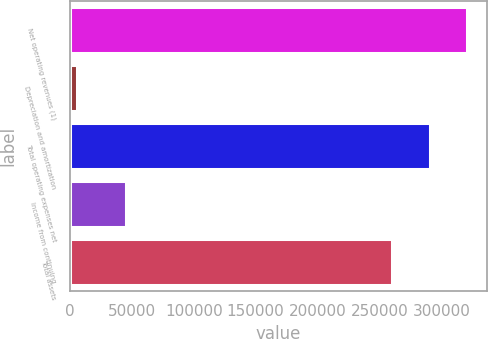Convert chart. <chart><loc_0><loc_0><loc_500><loc_500><bar_chart><fcel>Net operating revenues (1)<fcel>Depreciation and amortization<fcel>Total operating expenses net<fcel>Income from continuing<fcel>Total assets<nl><fcel>320616<fcel>5560<fcel>290436<fcel>44948<fcel>260255<nl></chart> 